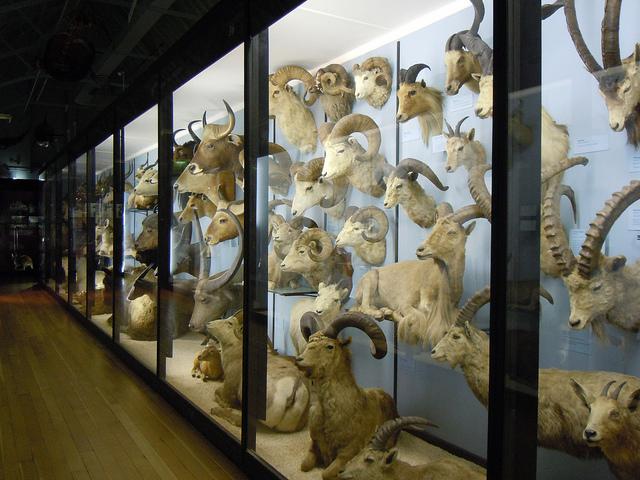What happened to these animals?
Quick response, please. Stuffed. What is blocking the view of the sheep?
Give a very brief answer. Glass. What are the animal heads in?
Give a very brief answer. Display case. What color is the wall the heads are on?
Give a very brief answer. Blue. 